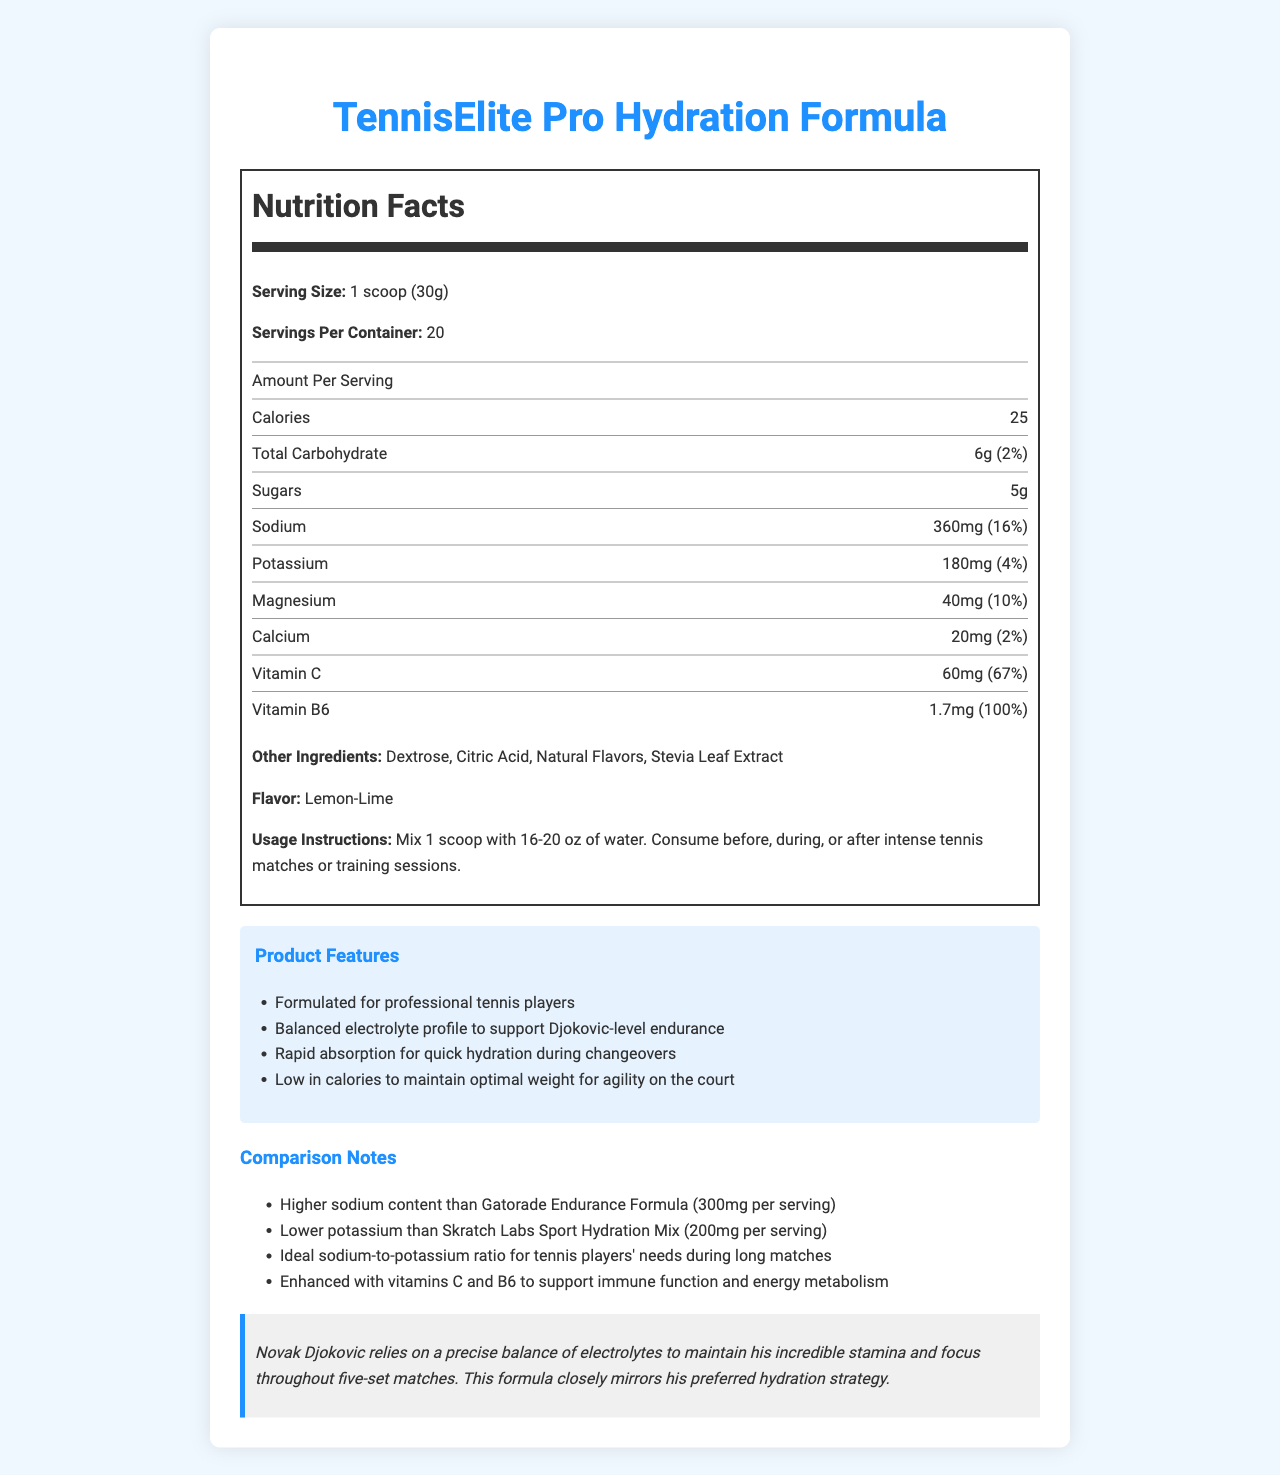what is the serving size of TennisElite Pro Hydration Formula? The document specifies the serving size as "1 scoop (30g)".
Answer: 1 scoop (30g) how many calories are in one serving? The Nutrition Facts section states that there are 25 calories per serving.
Answer: 25 how much sodium does one serving contain? The document lists the sodium content as 360mg per serving.
Answer: 360mg what is the daily value percentage of potassium per serving? The Nutrition Facts section mentions that the daily value percentage for potassium is 4%.
Answer: 4% list two other ingredients in the formula The document mentions various other ingredients, including Dextrose and Citric Acid.
Answer: Dextrose, Citric Acid what is the flavor of this hydration formula? A. Lemon-Lime B. Orange C. Berry Blast D. Coconut The document specifies that the flavor is Lemon-Lime.
Answer: A which vitamin has the highest daily value percentage per serving? A. Vitamin C B. Vitamin B6 C. Vitamin D D. Vitamin A The daily value for Vitamin B6 is 100%, which is the highest listed in the document.
Answer: B does the product contain any added sugars? The Nutrition Facts section lists 5g of sugars per serving.
Answer: Yes describe the main idea of the document The document includes comprehensive information about the hydration formula, such as its nutritional content, specific ingredients, advantages, comparisons with other products, and a player testimonial, making it clear that this product is formulated to meet the needs of high-endurance tennis players.
Answer: The document details the nutrition facts, ingredients, features, and comparison notes for the TennisElite Pro Hydration Formula, a product designed for professional tennis players, including an endorsement testimonial from Novak Djokovic. how does the sodium content of TennisElite Pro Hydration Formula compare to Gatorade Endurance Formula? The document states that TennisElite Pro has 360mg of sodium per serving, whereas Gatorade Endurance Formula has 300mg per serving.
Answer: TennisElite Pro has higher sodium content how many servings are in one container? The document states that there are 20 servings per container.
Answer: 20 is there any information about Djokovic’s preferred flavor for hydration supplements in the document? The document does not provide any information about Djokovic's preferred flavor.
Answer: No how much magnesium is in one serving according to the daily value percentage? The Nutrition Facts section lists the daily value percentage for magnesium as 10%.
Answer: 10% does TennisElite Pro Hydration Formula have more or less potassium than Skratch Labs Sport Hydration Mix? The document notes that TennisElite Pro has less potassium (180mg) compared to Skratch Labs Sport Hydration Mix (200mg).
Answer: Less what is the usage instruction for the product? A. Mix 1 scoop with 8-10 oz of water B. Mix 1 scoop with 12-15 oz of water C. Mix 1 scoop with 16-20 oz of water D. Mix 1 scoop with 20-24 oz of water The usage instruction is to mix 1 scoop with 16-20 oz of water.
Answer: C 